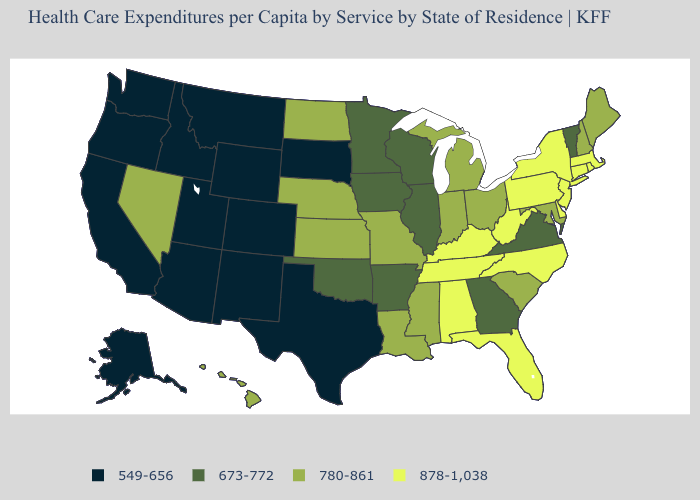Name the states that have a value in the range 780-861?
Quick response, please. Hawaii, Indiana, Kansas, Louisiana, Maine, Maryland, Michigan, Mississippi, Missouri, Nebraska, Nevada, New Hampshire, North Dakota, Ohio, South Carolina. What is the value of Minnesota?
Concise answer only. 673-772. What is the value of New Jersey?
Answer briefly. 878-1,038. What is the highest value in states that border Wisconsin?
Write a very short answer. 780-861. Name the states that have a value in the range 780-861?
Write a very short answer. Hawaii, Indiana, Kansas, Louisiana, Maine, Maryland, Michigan, Mississippi, Missouri, Nebraska, Nevada, New Hampshire, North Dakota, Ohio, South Carolina. Name the states that have a value in the range 673-772?
Concise answer only. Arkansas, Georgia, Illinois, Iowa, Minnesota, Oklahoma, Vermont, Virginia, Wisconsin. What is the value of Nebraska?
Keep it brief. 780-861. What is the value of South Carolina?
Write a very short answer. 780-861. What is the value of Minnesota?
Short answer required. 673-772. Does Colorado have the highest value in the USA?
Answer briefly. No. Does California have the highest value in the USA?
Write a very short answer. No. Among the states that border Ohio , does West Virginia have the highest value?
Quick response, please. Yes. Does Pennsylvania have the same value as North Carolina?
Be succinct. Yes. What is the value of Minnesota?
Be succinct. 673-772. Does Montana have the lowest value in the USA?
Be succinct. Yes. 